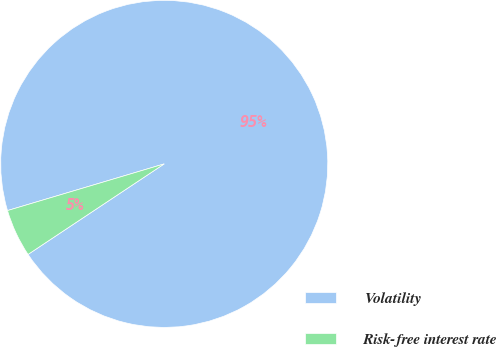Convert chart. <chart><loc_0><loc_0><loc_500><loc_500><pie_chart><fcel>Volatility<fcel>Risk-free interest rate<nl><fcel>95.27%<fcel>4.73%<nl></chart> 